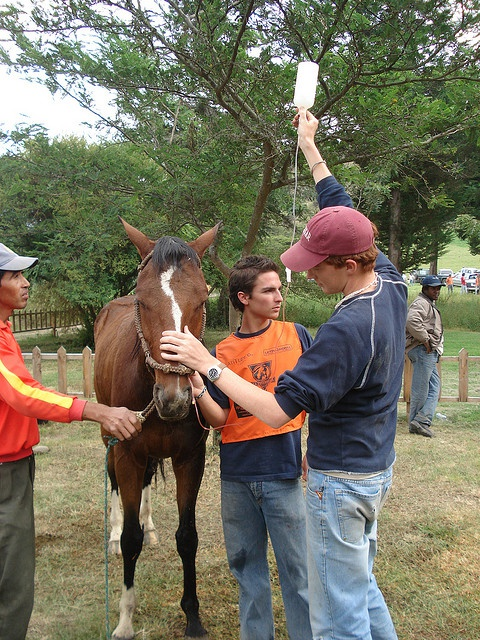Describe the objects in this image and their specific colors. I can see people in white, black, gray, and darkgray tones, horse in white, black, gray, maroon, and brown tones, people in white, gray, black, blue, and salmon tones, people in white, black, gray, and red tones, and people in white, gray, darkgray, and black tones in this image. 